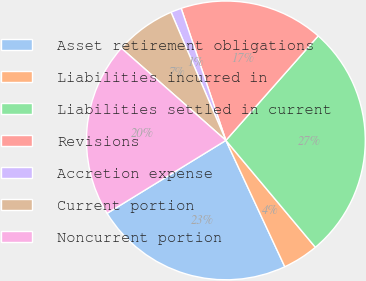Convert chart. <chart><loc_0><loc_0><loc_500><loc_500><pie_chart><fcel>Asset retirement obligations<fcel>Liabilities incurred in<fcel>Liabilities settled in current<fcel>Revisions<fcel>Accretion expense<fcel>Current portion<fcel>Noncurrent portion<nl><fcel>23.18%<fcel>4.15%<fcel>27.39%<fcel>16.71%<fcel>1.24%<fcel>7.06%<fcel>20.27%<nl></chart> 